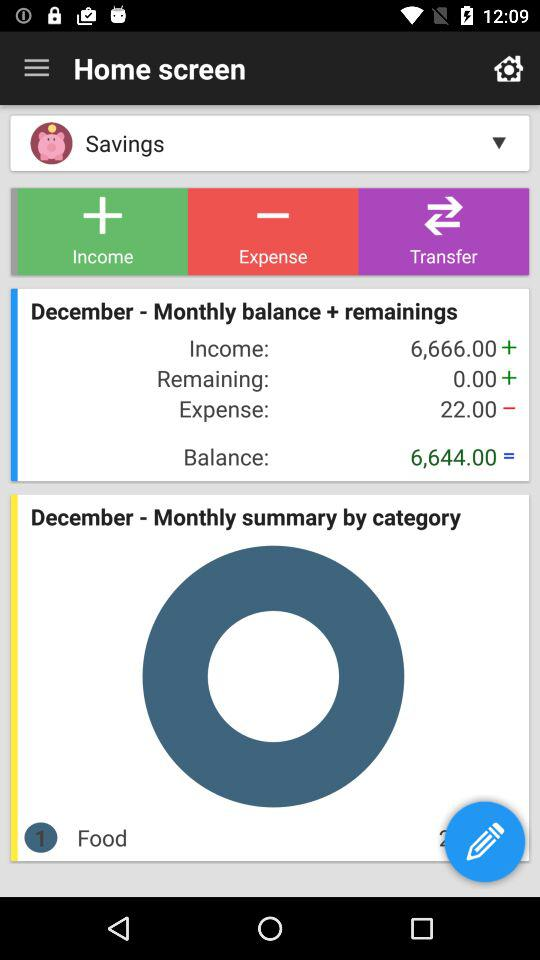What is the total amount of income?
Answer the question using a single word or phrase. 6,666.00 